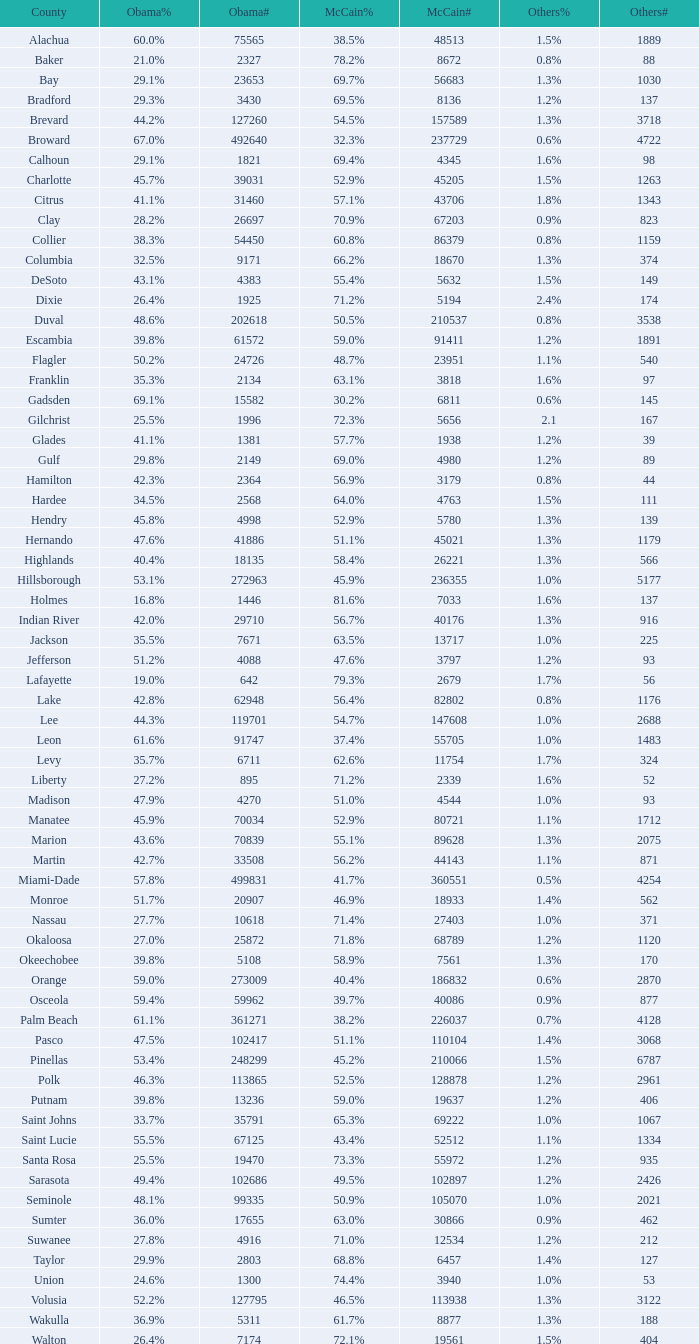When obama had 29.9% of voters, how many numbers were registered? 1.0. 